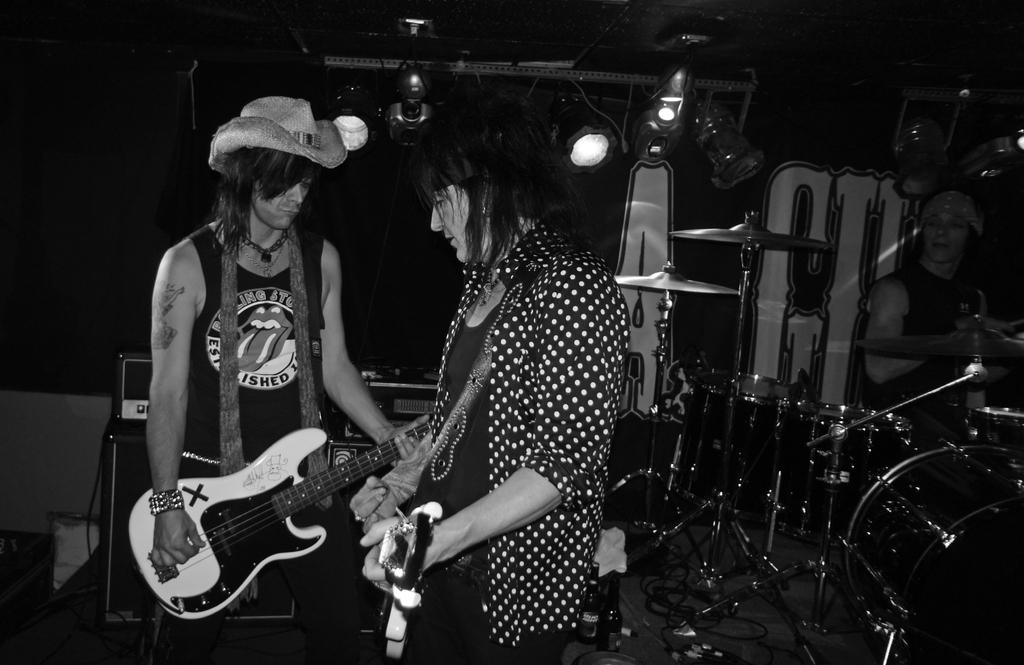What is the color scheme of the image? The image is black and white. What objects can be seen in the image? There are musical instruments in the image. How many persons are holding a guitar in the image? Two persons are holding a guitar in the image. Can you describe the attire of one of the persons in the image? One person is wearing a hat. What type of lighting is visible at the top of the image? There are focusing lights visible at the top of the image. Where is the lunchroom located in the image? There is no lunchroom present in the image. Can you tell me how many ants are crawling on the guitar in the image? There are no ants visible in the image, and therefore no such activity can be observed. 